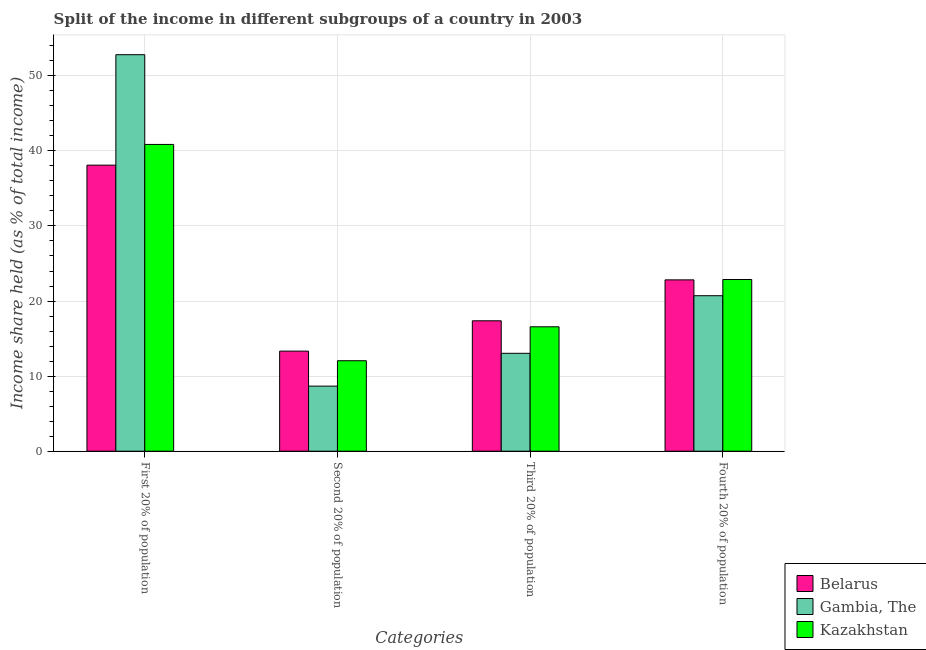How many groups of bars are there?
Your response must be concise. 4. Are the number of bars on each tick of the X-axis equal?
Provide a short and direct response. Yes. How many bars are there on the 1st tick from the right?
Give a very brief answer. 3. What is the label of the 1st group of bars from the left?
Offer a terse response. First 20% of population. What is the share of the income held by third 20% of the population in Kazakhstan?
Give a very brief answer. 16.57. Across all countries, what is the maximum share of the income held by fourth 20% of the population?
Provide a succinct answer. 22.87. Across all countries, what is the minimum share of the income held by fourth 20% of the population?
Your answer should be very brief. 20.71. In which country was the share of the income held by first 20% of the population maximum?
Offer a terse response. Gambia, The. In which country was the share of the income held by third 20% of the population minimum?
Offer a very short reply. Gambia, The. What is the total share of the income held by first 20% of the population in the graph?
Give a very brief answer. 131.77. What is the difference between the share of the income held by first 20% of the population in Belarus and that in Gambia, The?
Provide a short and direct response. -14.71. What is the difference between the share of the income held by first 20% of the population in Belarus and the share of the income held by third 20% of the population in Gambia, The?
Offer a very short reply. 25.06. What is the average share of the income held by first 20% of the population per country?
Provide a succinct answer. 43.92. What is the difference between the share of the income held by third 20% of the population and share of the income held by second 20% of the population in Kazakhstan?
Provide a succinct answer. 4.52. What is the ratio of the share of the income held by second 20% of the population in Belarus to that in Kazakhstan?
Your answer should be very brief. 1.11. What is the difference between the highest and the second highest share of the income held by second 20% of the population?
Ensure brevity in your answer.  1.28. What is the difference between the highest and the lowest share of the income held by first 20% of the population?
Your answer should be very brief. 14.71. What does the 3rd bar from the left in Third 20% of population represents?
Provide a succinct answer. Kazakhstan. What does the 1st bar from the right in Second 20% of population represents?
Your response must be concise. Kazakhstan. Is it the case that in every country, the sum of the share of the income held by first 20% of the population and share of the income held by second 20% of the population is greater than the share of the income held by third 20% of the population?
Offer a terse response. Yes. How many bars are there?
Offer a very short reply. 12. Are all the bars in the graph horizontal?
Keep it short and to the point. No. Does the graph contain any zero values?
Offer a very short reply. No. Does the graph contain grids?
Ensure brevity in your answer.  Yes. How many legend labels are there?
Offer a very short reply. 3. How are the legend labels stacked?
Offer a terse response. Vertical. What is the title of the graph?
Give a very brief answer. Split of the income in different subgroups of a country in 2003. What is the label or title of the X-axis?
Your answer should be very brief. Categories. What is the label or title of the Y-axis?
Your answer should be compact. Income share held (as % of total income). What is the Income share held (as % of total income) of Belarus in First 20% of population?
Provide a short and direct response. 38.1. What is the Income share held (as % of total income) of Gambia, The in First 20% of population?
Ensure brevity in your answer.  52.81. What is the Income share held (as % of total income) in Kazakhstan in First 20% of population?
Offer a terse response. 40.86. What is the Income share held (as % of total income) in Belarus in Second 20% of population?
Provide a short and direct response. 13.33. What is the Income share held (as % of total income) in Gambia, The in Second 20% of population?
Offer a terse response. 8.67. What is the Income share held (as % of total income) in Kazakhstan in Second 20% of population?
Your response must be concise. 12.05. What is the Income share held (as % of total income) of Belarus in Third 20% of population?
Offer a very short reply. 17.37. What is the Income share held (as % of total income) in Gambia, The in Third 20% of population?
Give a very brief answer. 13.04. What is the Income share held (as % of total income) of Kazakhstan in Third 20% of population?
Offer a very short reply. 16.57. What is the Income share held (as % of total income) of Belarus in Fourth 20% of population?
Offer a very short reply. 22.82. What is the Income share held (as % of total income) in Gambia, The in Fourth 20% of population?
Ensure brevity in your answer.  20.71. What is the Income share held (as % of total income) in Kazakhstan in Fourth 20% of population?
Provide a succinct answer. 22.87. Across all Categories, what is the maximum Income share held (as % of total income) of Belarus?
Your response must be concise. 38.1. Across all Categories, what is the maximum Income share held (as % of total income) of Gambia, The?
Give a very brief answer. 52.81. Across all Categories, what is the maximum Income share held (as % of total income) of Kazakhstan?
Give a very brief answer. 40.86. Across all Categories, what is the minimum Income share held (as % of total income) in Belarus?
Offer a terse response. 13.33. Across all Categories, what is the minimum Income share held (as % of total income) in Gambia, The?
Make the answer very short. 8.67. Across all Categories, what is the minimum Income share held (as % of total income) of Kazakhstan?
Your response must be concise. 12.05. What is the total Income share held (as % of total income) in Belarus in the graph?
Make the answer very short. 91.62. What is the total Income share held (as % of total income) in Gambia, The in the graph?
Ensure brevity in your answer.  95.23. What is the total Income share held (as % of total income) of Kazakhstan in the graph?
Your response must be concise. 92.35. What is the difference between the Income share held (as % of total income) of Belarus in First 20% of population and that in Second 20% of population?
Your answer should be very brief. 24.77. What is the difference between the Income share held (as % of total income) in Gambia, The in First 20% of population and that in Second 20% of population?
Keep it short and to the point. 44.14. What is the difference between the Income share held (as % of total income) of Kazakhstan in First 20% of population and that in Second 20% of population?
Your answer should be very brief. 28.81. What is the difference between the Income share held (as % of total income) of Belarus in First 20% of population and that in Third 20% of population?
Give a very brief answer. 20.73. What is the difference between the Income share held (as % of total income) of Gambia, The in First 20% of population and that in Third 20% of population?
Your answer should be very brief. 39.77. What is the difference between the Income share held (as % of total income) of Kazakhstan in First 20% of population and that in Third 20% of population?
Your answer should be very brief. 24.29. What is the difference between the Income share held (as % of total income) in Belarus in First 20% of population and that in Fourth 20% of population?
Offer a very short reply. 15.28. What is the difference between the Income share held (as % of total income) of Gambia, The in First 20% of population and that in Fourth 20% of population?
Your answer should be compact. 32.1. What is the difference between the Income share held (as % of total income) of Kazakhstan in First 20% of population and that in Fourth 20% of population?
Your answer should be very brief. 17.99. What is the difference between the Income share held (as % of total income) in Belarus in Second 20% of population and that in Third 20% of population?
Your answer should be very brief. -4.04. What is the difference between the Income share held (as % of total income) of Gambia, The in Second 20% of population and that in Third 20% of population?
Your answer should be very brief. -4.37. What is the difference between the Income share held (as % of total income) in Kazakhstan in Second 20% of population and that in Third 20% of population?
Offer a very short reply. -4.52. What is the difference between the Income share held (as % of total income) in Belarus in Second 20% of population and that in Fourth 20% of population?
Keep it short and to the point. -9.49. What is the difference between the Income share held (as % of total income) in Gambia, The in Second 20% of population and that in Fourth 20% of population?
Provide a short and direct response. -12.04. What is the difference between the Income share held (as % of total income) in Kazakhstan in Second 20% of population and that in Fourth 20% of population?
Your answer should be very brief. -10.82. What is the difference between the Income share held (as % of total income) in Belarus in Third 20% of population and that in Fourth 20% of population?
Make the answer very short. -5.45. What is the difference between the Income share held (as % of total income) of Gambia, The in Third 20% of population and that in Fourth 20% of population?
Provide a short and direct response. -7.67. What is the difference between the Income share held (as % of total income) in Kazakhstan in Third 20% of population and that in Fourth 20% of population?
Keep it short and to the point. -6.3. What is the difference between the Income share held (as % of total income) in Belarus in First 20% of population and the Income share held (as % of total income) in Gambia, The in Second 20% of population?
Offer a terse response. 29.43. What is the difference between the Income share held (as % of total income) of Belarus in First 20% of population and the Income share held (as % of total income) of Kazakhstan in Second 20% of population?
Your answer should be very brief. 26.05. What is the difference between the Income share held (as % of total income) of Gambia, The in First 20% of population and the Income share held (as % of total income) of Kazakhstan in Second 20% of population?
Your response must be concise. 40.76. What is the difference between the Income share held (as % of total income) in Belarus in First 20% of population and the Income share held (as % of total income) in Gambia, The in Third 20% of population?
Your answer should be very brief. 25.06. What is the difference between the Income share held (as % of total income) in Belarus in First 20% of population and the Income share held (as % of total income) in Kazakhstan in Third 20% of population?
Keep it short and to the point. 21.53. What is the difference between the Income share held (as % of total income) in Gambia, The in First 20% of population and the Income share held (as % of total income) in Kazakhstan in Third 20% of population?
Ensure brevity in your answer.  36.24. What is the difference between the Income share held (as % of total income) of Belarus in First 20% of population and the Income share held (as % of total income) of Gambia, The in Fourth 20% of population?
Your answer should be very brief. 17.39. What is the difference between the Income share held (as % of total income) of Belarus in First 20% of population and the Income share held (as % of total income) of Kazakhstan in Fourth 20% of population?
Provide a short and direct response. 15.23. What is the difference between the Income share held (as % of total income) of Gambia, The in First 20% of population and the Income share held (as % of total income) of Kazakhstan in Fourth 20% of population?
Give a very brief answer. 29.94. What is the difference between the Income share held (as % of total income) of Belarus in Second 20% of population and the Income share held (as % of total income) of Gambia, The in Third 20% of population?
Offer a terse response. 0.29. What is the difference between the Income share held (as % of total income) in Belarus in Second 20% of population and the Income share held (as % of total income) in Kazakhstan in Third 20% of population?
Provide a succinct answer. -3.24. What is the difference between the Income share held (as % of total income) in Belarus in Second 20% of population and the Income share held (as % of total income) in Gambia, The in Fourth 20% of population?
Offer a very short reply. -7.38. What is the difference between the Income share held (as % of total income) in Belarus in Second 20% of population and the Income share held (as % of total income) in Kazakhstan in Fourth 20% of population?
Provide a short and direct response. -9.54. What is the difference between the Income share held (as % of total income) of Belarus in Third 20% of population and the Income share held (as % of total income) of Gambia, The in Fourth 20% of population?
Give a very brief answer. -3.34. What is the difference between the Income share held (as % of total income) in Gambia, The in Third 20% of population and the Income share held (as % of total income) in Kazakhstan in Fourth 20% of population?
Provide a short and direct response. -9.83. What is the average Income share held (as % of total income) in Belarus per Categories?
Provide a short and direct response. 22.91. What is the average Income share held (as % of total income) in Gambia, The per Categories?
Your answer should be compact. 23.81. What is the average Income share held (as % of total income) in Kazakhstan per Categories?
Ensure brevity in your answer.  23.09. What is the difference between the Income share held (as % of total income) in Belarus and Income share held (as % of total income) in Gambia, The in First 20% of population?
Provide a succinct answer. -14.71. What is the difference between the Income share held (as % of total income) of Belarus and Income share held (as % of total income) of Kazakhstan in First 20% of population?
Offer a terse response. -2.76. What is the difference between the Income share held (as % of total income) of Gambia, The and Income share held (as % of total income) of Kazakhstan in First 20% of population?
Your answer should be compact. 11.95. What is the difference between the Income share held (as % of total income) in Belarus and Income share held (as % of total income) in Gambia, The in Second 20% of population?
Provide a succinct answer. 4.66. What is the difference between the Income share held (as % of total income) of Belarus and Income share held (as % of total income) of Kazakhstan in Second 20% of population?
Make the answer very short. 1.28. What is the difference between the Income share held (as % of total income) in Gambia, The and Income share held (as % of total income) in Kazakhstan in Second 20% of population?
Ensure brevity in your answer.  -3.38. What is the difference between the Income share held (as % of total income) of Belarus and Income share held (as % of total income) of Gambia, The in Third 20% of population?
Offer a very short reply. 4.33. What is the difference between the Income share held (as % of total income) in Gambia, The and Income share held (as % of total income) in Kazakhstan in Third 20% of population?
Give a very brief answer. -3.53. What is the difference between the Income share held (as % of total income) of Belarus and Income share held (as % of total income) of Gambia, The in Fourth 20% of population?
Your response must be concise. 2.11. What is the difference between the Income share held (as % of total income) of Gambia, The and Income share held (as % of total income) of Kazakhstan in Fourth 20% of population?
Provide a short and direct response. -2.16. What is the ratio of the Income share held (as % of total income) in Belarus in First 20% of population to that in Second 20% of population?
Make the answer very short. 2.86. What is the ratio of the Income share held (as % of total income) in Gambia, The in First 20% of population to that in Second 20% of population?
Provide a short and direct response. 6.09. What is the ratio of the Income share held (as % of total income) in Kazakhstan in First 20% of population to that in Second 20% of population?
Offer a terse response. 3.39. What is the ratio of the Income share held (as % of total income) in Belarus in First 20% of population to that in Third 20% of population?
Make the answer very short. 2.19. What is the ratio of the Income share held (as % of total income) of Gambia, The in First 20% of population to that in Third 20% of population?
Ensure brevity in your answer.  4.05. What is the ratio of the Income share held (as % of total income) of Kazakhstan in First 20% of population to that in Third 20% of population?
Offer a very short reply. 2.47. What is the ratio of the Income share held (as % of total income) of Belarus in First 20% of population to that in Fourth 20% of population?
Provide a succinct answer. 1.67. What is the ratio of the Income share held (as % of total income) in Gambia, The in First 20% of population to that in Fourth 20% of population?
Offer a terse response. 2.55. What is the ratio of the Income share held (as % of total income) of Kazakhstan in First 20% of population to that in Fourth 20% of population?
Provide a short and direct response. 1.79. What is the ratio of the Income share held (as % of total income) of Belarus in Second 20% of population to that in Third 20% of population?
Give a very brief answer. 0.77. What is the ratio of the Income share held (as % of total income) in Gambia, The in Second 20% of population to that in Third 20% of population?
Give a very brief answer. 0.66. What is the ratio of the Income share held (as % of total income) of Kazakhstan in Second 20% of population to that in Third 20% of population?
Make the answer very short. 0.73. What is the ratio of the Income share held (as % of total income) in Belarus in Second 20% of population to that in Fourth 20% of population?
Provide a short and direct response. 0.58. What is the ratio of the Income share held (as % of total income) of Gambia, The in Second 20% of population to that in Fourth 20% of population?
Provide a short and direct response. 0.42. What is the ratio of the Income share held (as % of total income) of Kazakhstan in Second 20% of population to that in Fourth 20% of population?
Your answer should be very brief. 0.53. What is the ratio of the Income share held (as % of total income) of Belarus in Third 20% of population to that in Fourth 20% of population?
Your answer should be compact. 0.76. What is the ratio of the Income share held (as % of total income) of Gambia, The in Third 20% of population to that in Fourth 20% of population?
Offer a terse response. 0.63. What is the ratio of the Income share held (as % of total income) of Kazakhstan in Third 20% of population to that in Fourth 20% of population?
Your answer should be very brief. 0.72. What is the difference between the highest and the second highest Income share held (as % of total income) in Belarus?
Keep it short and to the point. 15.28. What is the difference between the highest and the second highest Income share held (as % of total income) in Gambia, The?
Ensure brevity in your answer.  32.1. What is the difference between the highest and the second highest Income share held (as % of total income) of Kazakhstan?
Your answer should be very brief. 17.99. What is the difference between the highest and the lowest Income share held (as % of total income) of Belarus?
Your response must be concise. 24.77. What is the difference between the highest and the lowest Income share held (as % of total income) in Gambia, The?
Your answer should be very brief. 44.14. What is the difference between the highest and the lowest Income share held (as % of total income) in Kazakhstan?
Make the answer very short. 28.81. 